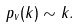<formula> <loc_0><loc_0><loc_500><loc_500>p _ { v } ( k ) \sim k .</formula> 